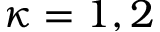Convert formula to latex. <formula><loc_0><loc_0><loc_500><loc_500>\kappa = 1 , 2</formula> 